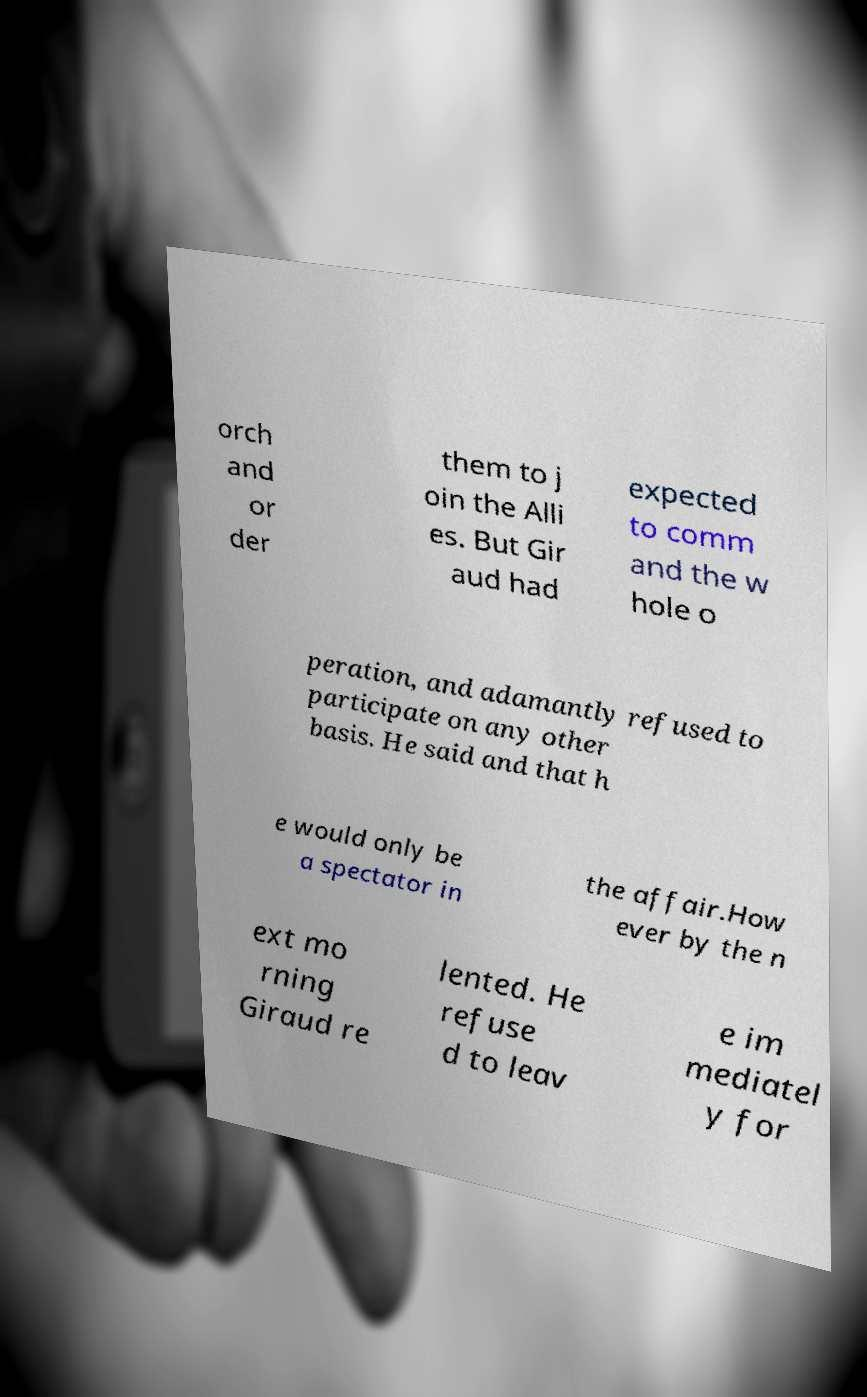I need the written content from this picture converted into text. Can you do that? orch and or der them to j oin the Alli es. But Gir aud had expected to comm and the w hole o peration, and adamantly refused to participate on any other basis. He said and that h e would only be a spectator in the affair.How ever by the n ext mo rning Giraud re lented. He refuse d to leav e im mediatel y for 